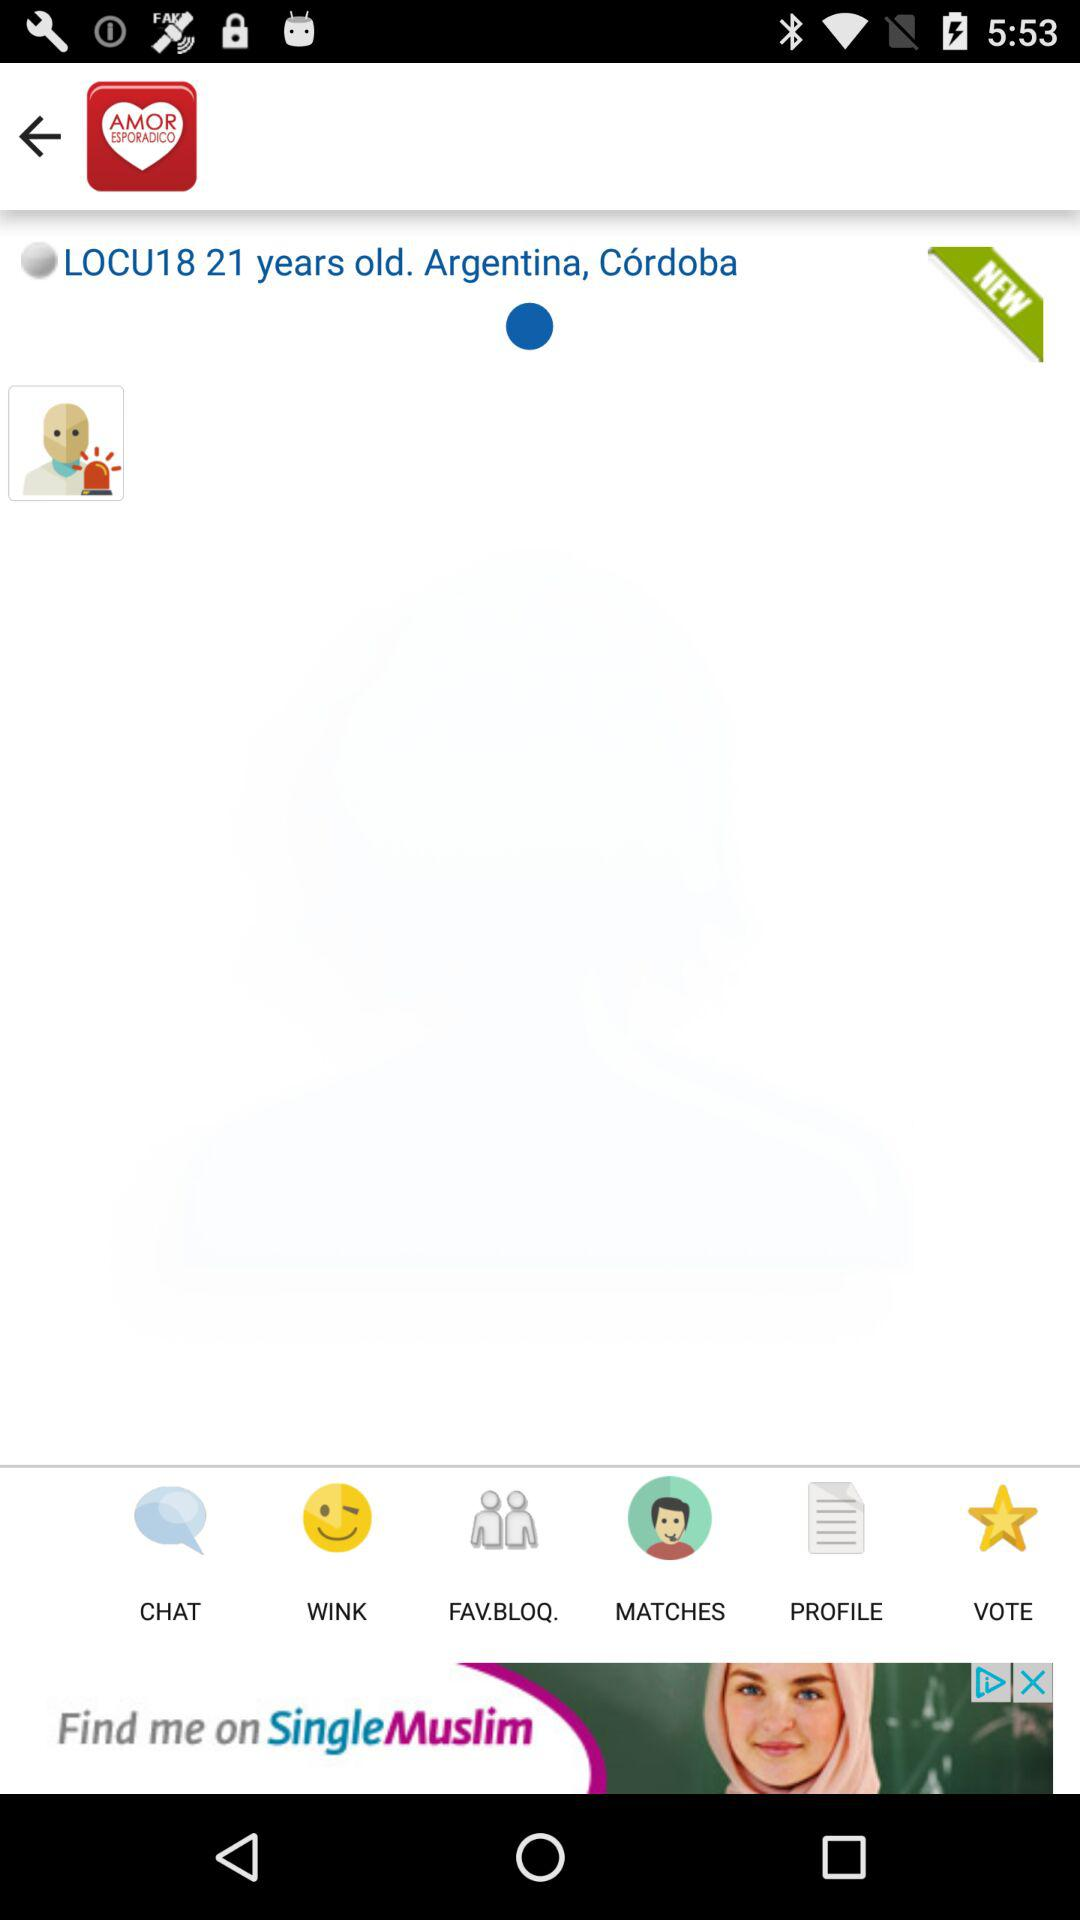What country does the user belong to? The user belongs to Argentina. 